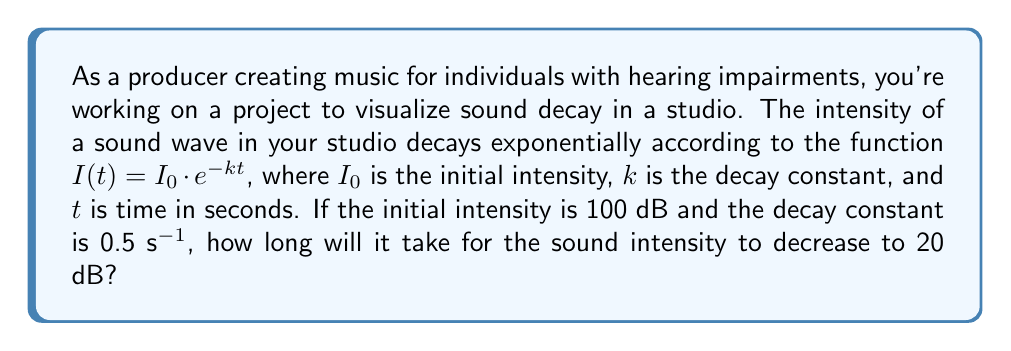Could you help me with this problem? To solve this problem, we'll use the exponential decay function and logarithms. Let's break it down step-by-step:

1) We're given the exponential decay function:
   $I(t) = I_0 \cdot e^{-kt}$

2) We know:
   $I_0 = 100$ dB (initial intensity)
   $k = 0.5$ s^-1 (decay constant)
   $I(t) = 20$ dB (final intensity)

3) Let's plug these values into the equation:
   $20 = 100 \cdot e^{-0.5t}$

4) To solve for $t$, we first divide both sides by 100:
   $\frac{20}{100} = e^{-0.5t}$
   $0.2 = e^{-0.5t}$

5) Now, we take the natural logarithm of both sides:
   $\ln(0.2) = \ln(e^{-0.5t})$

6) Using the logarithm property $\ln(e^x) = x$, we get:
   $\ln(0.2) = -0.5t$

7) Solve for $t$ by dividing both sides by -0.5:
   $t = \frac{\ln(0.2)}{-0.5}$

8) Calculate the result:
   $t = \frac{-1.60944...}{-0.5} \approx 3.2189$ seconds

Therefore, it will take approximately 3.22 seconds for the sound intensity to decrease from 100 dB to 20 dB.
Answer: $t \approx 3.22$ seconds 